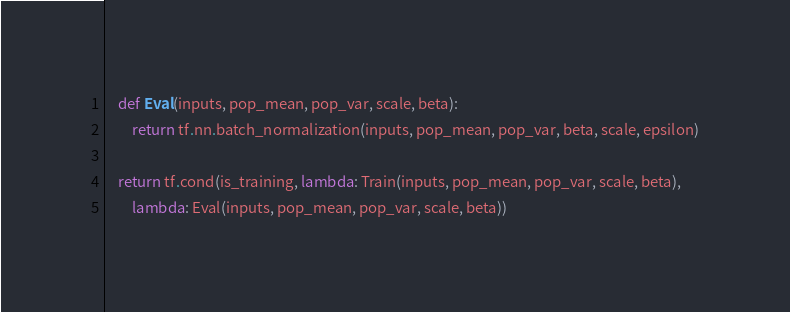<code> <loc_0><loc_0><loc_500><loc_500><_Python_>	def Eval(inputs, pop_mean, pop_var, scale, beta):
		return tf.nn.batch_normalization(inputs, pop_mean, pop_var, beta, scale, epsilon)

	return tf.cond(is_training, lambda: Train(inputs, pop_mean, pop_var, scale, beta),
		lambda: Eval(inputs, pop_mean, pop_var, scale, beta))


</code> 